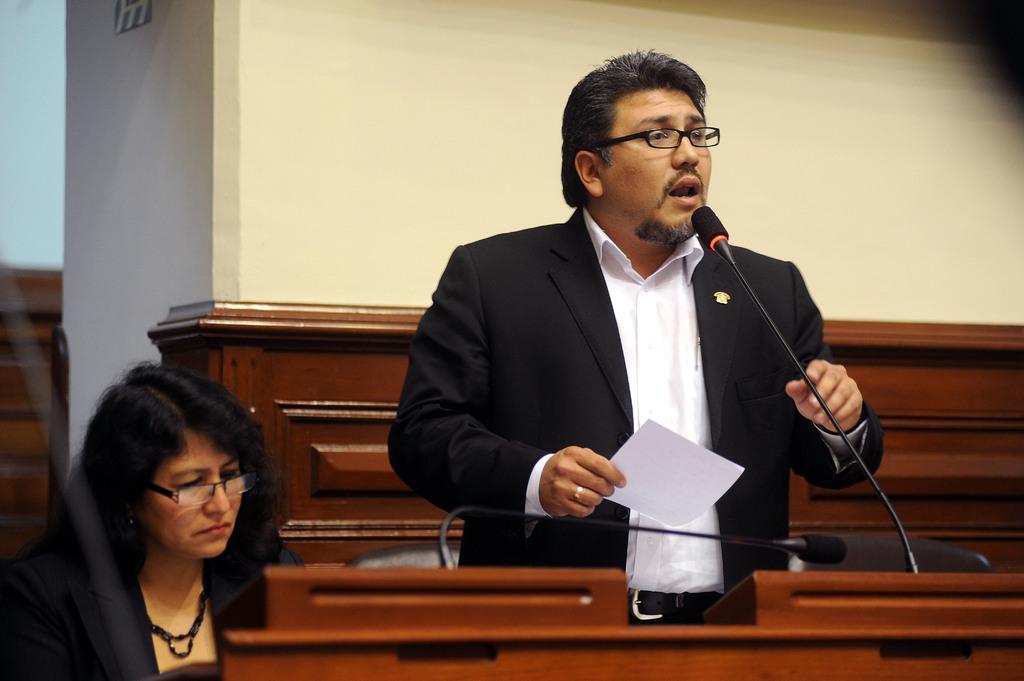Please provide a concise description of this image. In the foreground of the picture there are tables, chairs, mic, a woman and a man. The man is standing, he is holding a paper and speaking. In the background it is well. 